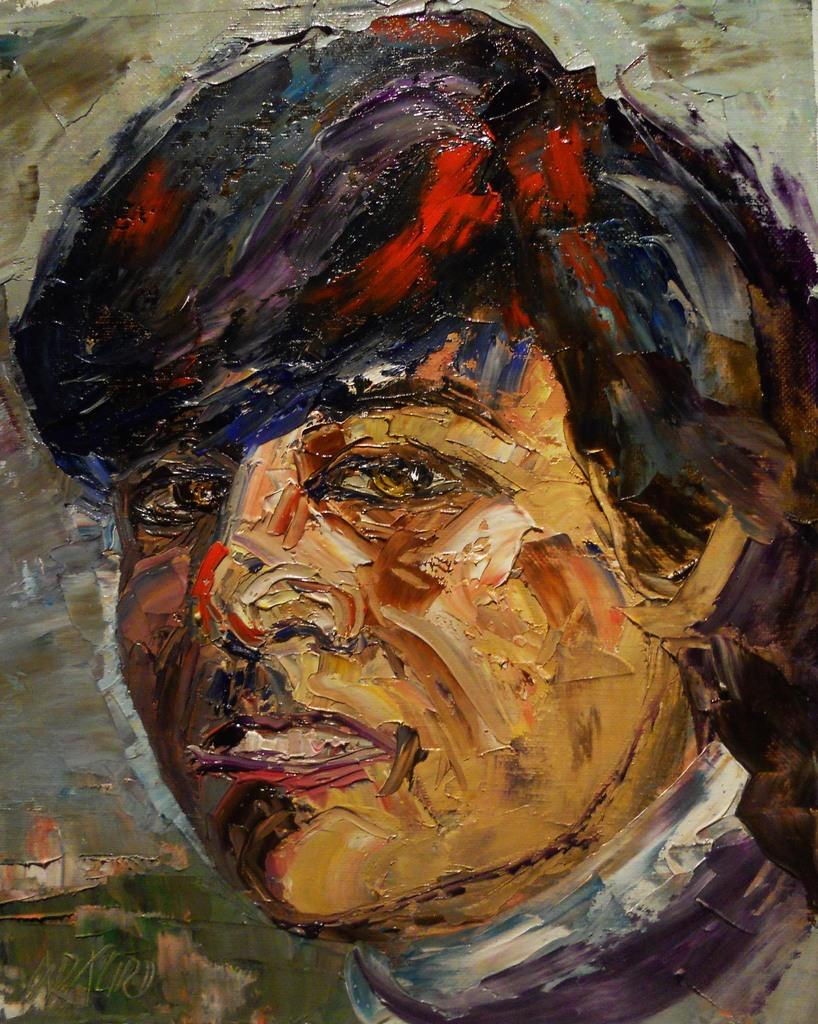What is the main subject of the painting in the image? There is a painting of a person in the image. Is there a veil covering the person's face in the painting? There is no mention of a veil in the provided facts, so we cannot determine if the person's face is covered. Can you describe the cat sitting next to the person in the painting? There is no mention of a cat in the provided facts, so we cannot describe any such animal in the painting. 